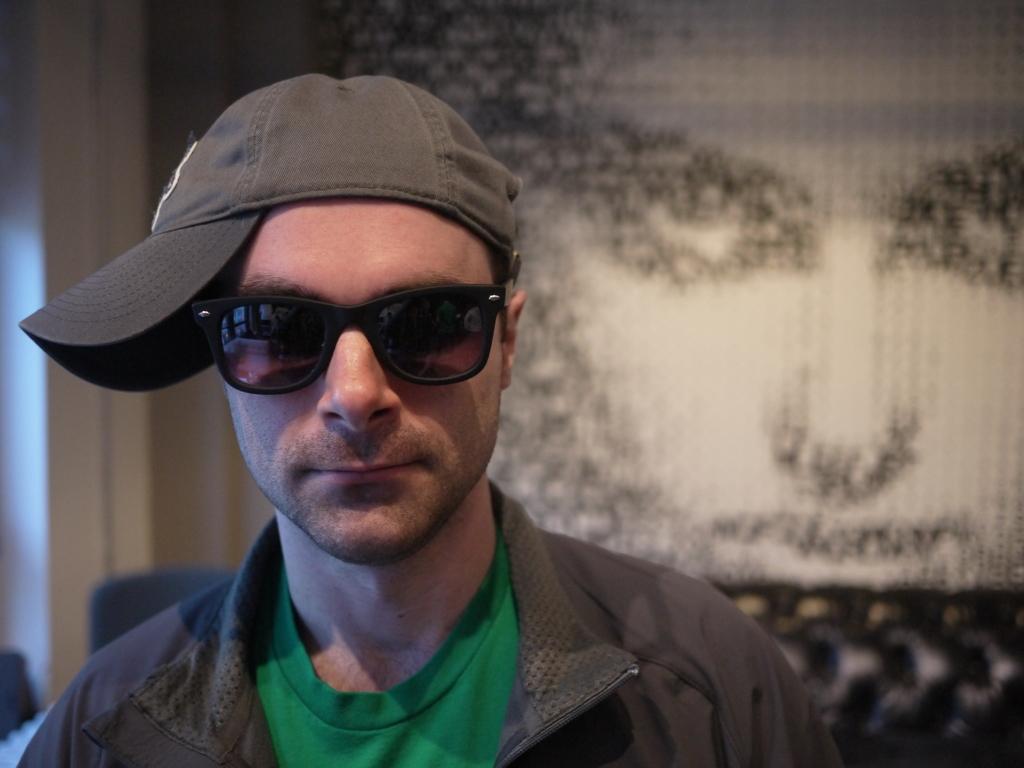Please provide a concise description of this image. In this image I can see a person. He is wearing spectacles. He is wearing a cap. In the background it is looking like a painting. 